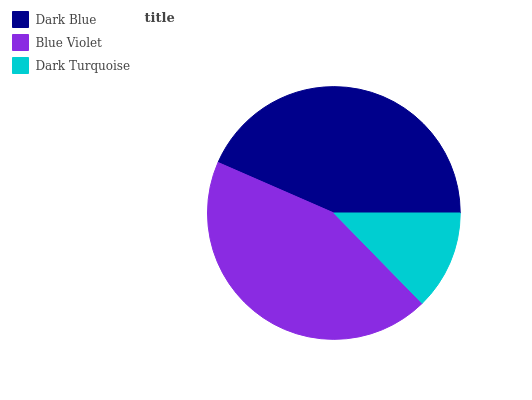Is Dark Turquoise the minimum?
Answer yes or no. Yes. Is Blue Violet the maximum?
Answer yes or no. Yes. Is Blue Violet the minimum?
Answer yes or no. No. Is Dark Turquoise the maximum?
Answer yes or no. No. Is Blue Violet greater than Dark Turquoise?
Answer yes or no. Yes. Is Dark Turquoise less than Blue Violet?
Answer yes or no. Yes. Is Dark Turquoise greater than Blue Violet?
Answer yes or no. No. Is Blue Violet less than Dark Turquoise?
Answer yes or no. No. Is Dark Blue the high median?
Answer yes or no. Yes. Is Dark Blue the low median?
Answer yes or no. Yes. Is Dark Turquoise the high median?
Answer yes or no. No. Is Dark Turquoise the low median?
Answer yes or no. No. 